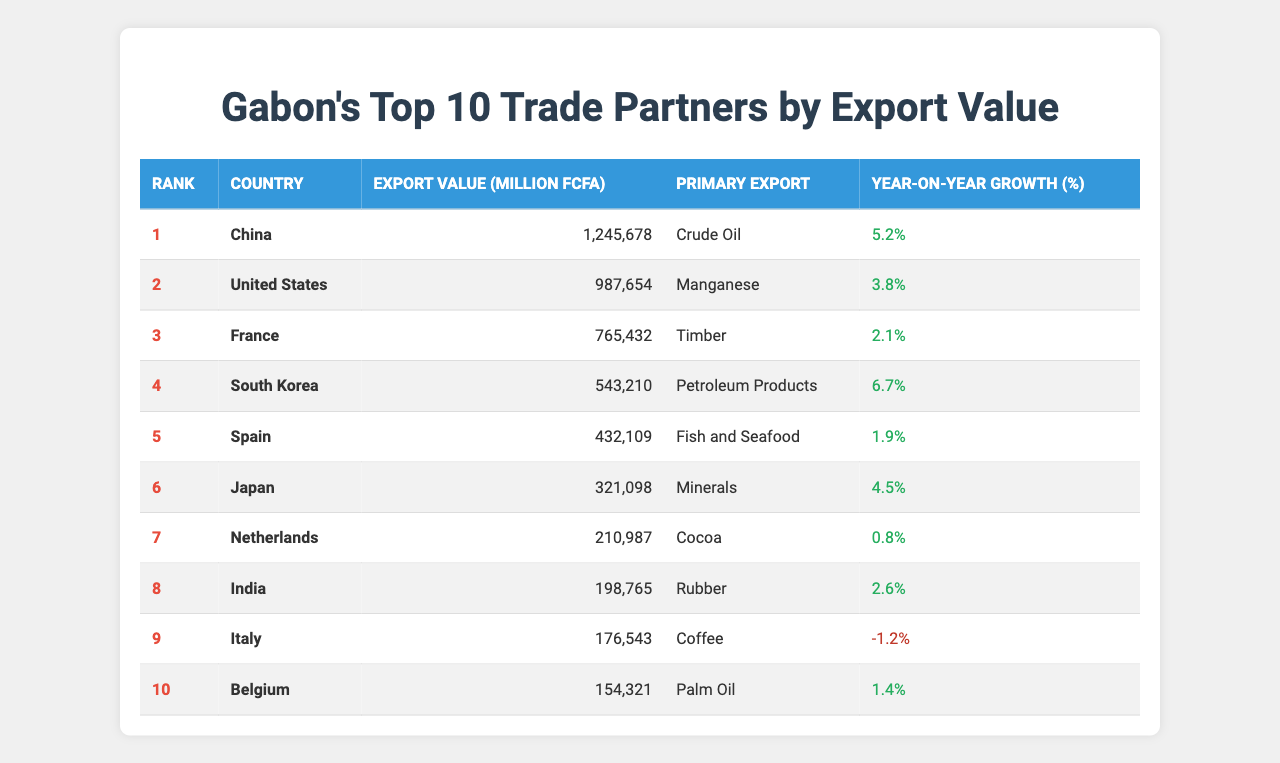What is Gabon's top trade partner by export value? The table lists the trade partners by export value, with China ranked first at 1,245,678 million FCFA.
Answer: China Which country exported the most manganese to Gabon? The table specifies that the United States is the second-ranked trade partner, primarily exporting manganese.
Answer: United States What is the export value of Japan's exports? Japan's export value is listed in the table as 321,098 million FCFA.
Answer: 321098 million FCFA How many countries have a year-on-year growth rate higher than 5%? By examining the year-on-year growth percentages, China (5.2%) and South Korea (6.7%) are the only two with values greater than 5%.
Answer: 2 Which country saw a decline in export value compared to the previous year? Italy's year-on-year growth is -1.2%, indicating a decline in export value from the previous year.
Answer: Italy What is the average export value of the top 10 trade partners? To find the average, sum the export values (1245678 + 987654 + 765432 + 543210 + 432109 + 321098 + 210987 + 198765 + 176543 + 154321 = 3377337) and divide by 10, resulting in an average of 337733.7 million FCFA.
Answer: 337733.7 million FCFA Which export has the highest value for Belgium? According to the table, Belgium's primary export is palm oil.
Answer: Palm oil Is France ranked higher than Spain in export value? The rank for France is 3 and for Spain is 5, confirming that France is indeed ranked higher than Spain.
Answer: Yes What is the total export value of the top three trade partners? Adding the export values of the top three partners gives: 1245678 + 987654 + 765432 = 3025764 million FCFA.
Answer: 3025764 million FCFA Which country has the lowest export value among the top 10 trade partners? The table shows that Belgium has the lowest export value at 154,321 million FCFA.
Answer: Belgium 